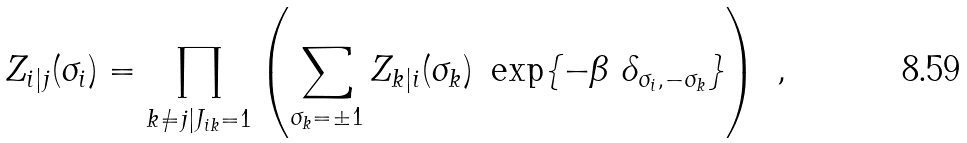<formula> <loc_0><loc_0><loc_500><loc_500>Z _ { i | j } ( \sigma _ { i } ) = \prod _ { k \neq j | J _ { i k } = 1 } \left ( \sum _ { \sigma _ { k } = \pm 1 } Z _ { k | i } ( \sigma _ { k } ) \ \exp \{ - \beta \ \delta _ { \sigma _ { i } , - \sigma _ { k } } \} \right ) \ ,</formula> 